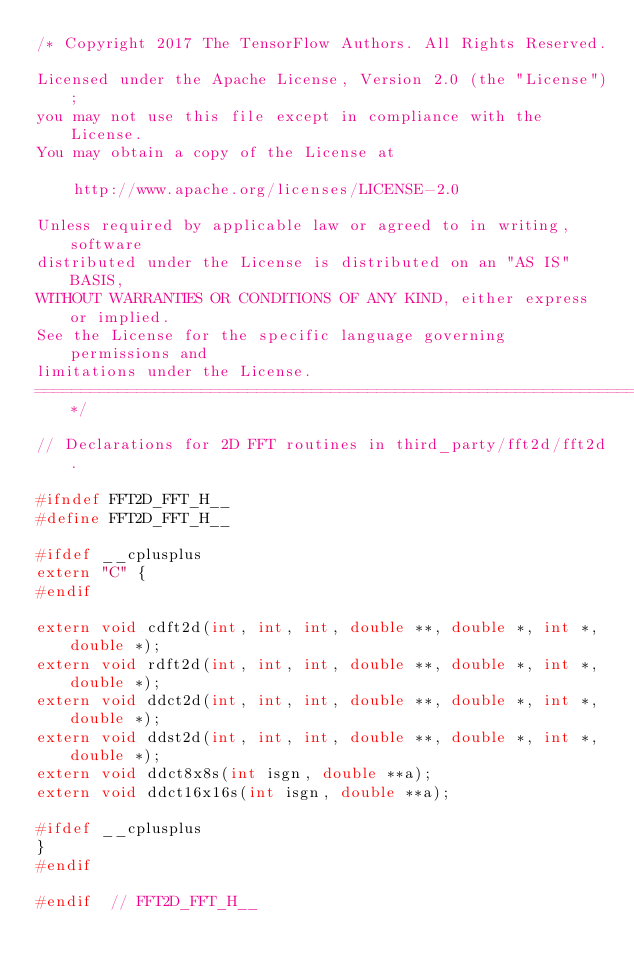Convert code to text. <code><loc_0><loc_0><loc_500><loc_500><_C_>/* Copyright 2017 The TensorFlow Authors. All Rights Reserved.

Licensed under the Apache License, Version 2.0 (the "License");
you may not use this file except in compliance with the License.
You may obtain a copy of the License at

    http://www.apache.org/licenses/LICENSE-2.0

Unless required by applicable law or agreed to in writing, software
distributed under the License is distributed on an "AS IS" BASIS,
WITHOUT WARRANTIES OR CONDITIONS OF ANY KIND, either express or implied.
See the License for the specific language governing permissions and
limitations under the License.
==============================================================================*/

// Declarations for 2D FFT routines in third_party/fft2d/fft2d.

#ifndef FFT2D_FFT_H__
#define FFT2D_FFT_H__

#ifdef __cplusplus
extern "C" {
#endif

extern void cdft2d(int, int, int, double **, double *, int *, double *);
extern void rdft2d(int, int, int, double **, double *, int *, double *);
extern void ddct2d(int, int, int, double **, double *, int *, double *);
extern void ddst2d(int, int, int, double **, double *, int *, double *);
extern void ddct8x8s(int isgn, double **a);
extern void ddct16x16s(int isgn, double **a);

#ifdef __cplusplus
}
#endif

#endif  // FFT2D_FFT_H__
</code> 